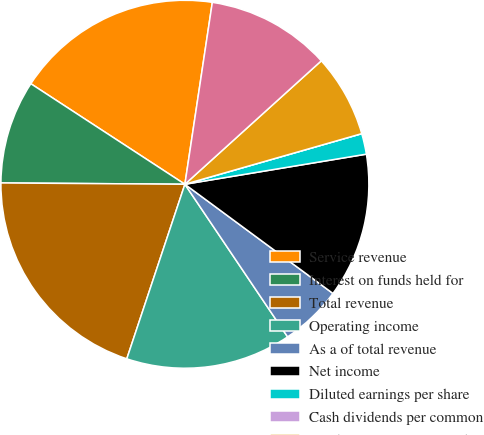<chart> <loc_0><loc_0><loc_500><loc_500><pie_chart><fcel>Service revenue<fcel>Interest on funds held for<fcel>Total revenue<fcel>Operating income<fcel>As a of total revenue<fcel>Net income<fcel>Diluted earnings per share<fcel>Cash dividends per common<fcel>Purchases of property and<fcel>Cash and total corporate<nl><fcel>18.18%<fcel>9.09%<fcel>20.0%<fcel>14.54%<fcel>5.46%<fcel>12.73%<fcel>1.82%<fcel>0.0%<fcel>7.27%<fcel>10.91%<nl></chart> 